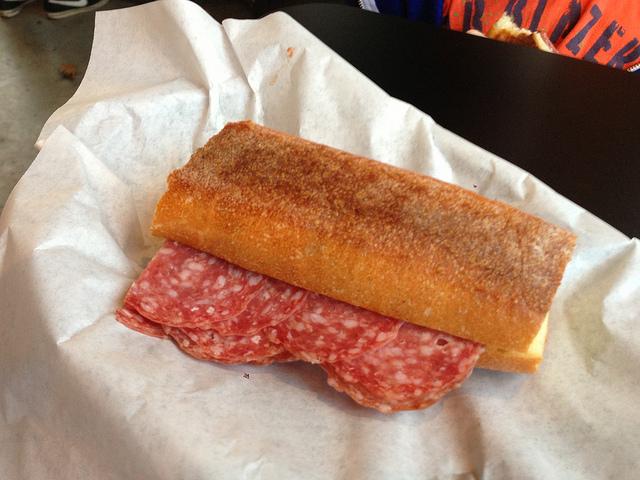What is the sandwich sitting on?
Give a very brief answer. Paper. How many pieces of bread are there?
Quick response, please. 2. What type of meat is this?
Be succinct. Salami. Can you see pancakes?
Quick response, please. No. What is on the sandwich?
Concise answer only. Salami. 